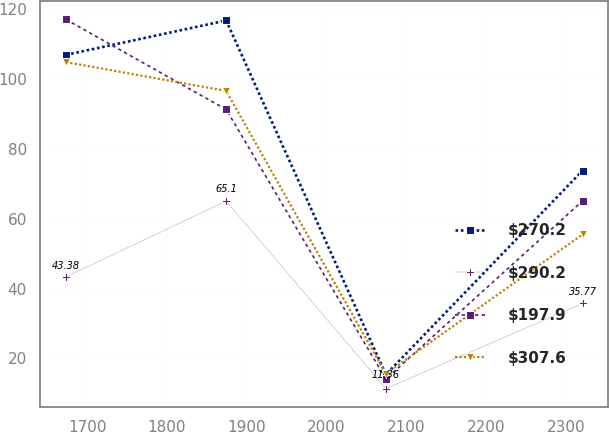Convert chart to OTSL. <chart><loc_0><loc_0><loc_500><loc_500><line_chart><ecel><fcel>$270.2<fcel>$290.2<fcel>$197.9<fcel>$307.6<nl><fcel>1673.2<fcel>106.99<fcel>43.38<fcel>117.14<fcel>104.92<nl><fcel>1874.17<fcel>116.84<fcel>65.1<fcel>91.34<fcel>96.65<nl><fcel>2074.49<fcel>15.38<fcel>11.36<fcel>14.1<fcel>15.61<nl><fcel>2321.27<fcel>73.85<fcel>35.77<fcel>65.17<fcel>55.54<nl></chart> 